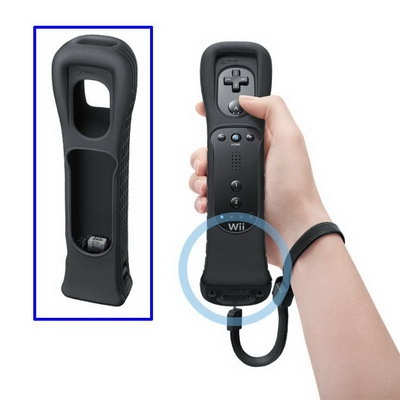Describe the objects in this image and their specific colors. I can see people in white, tan, darkgray, and lightgray tones and remote in white, black, gray, and darkgray tones in this image. 